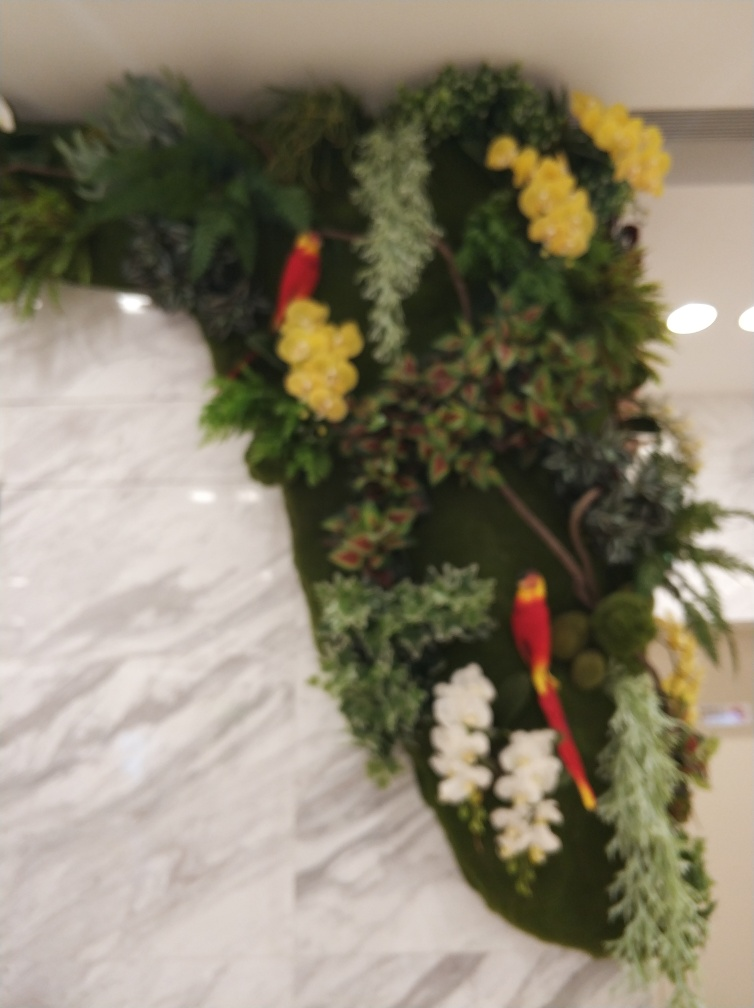What is the condition of the main subject, the bird? While the condition of the bird can be described as slightly blurry, as the image lacks sharpness, making fine textures difficult to discern, the bird itself is still relatively distinguishable. The colors appear vivid, which partially compensates for the lack of sharpness and allows viewers to identify the object as a bird. 